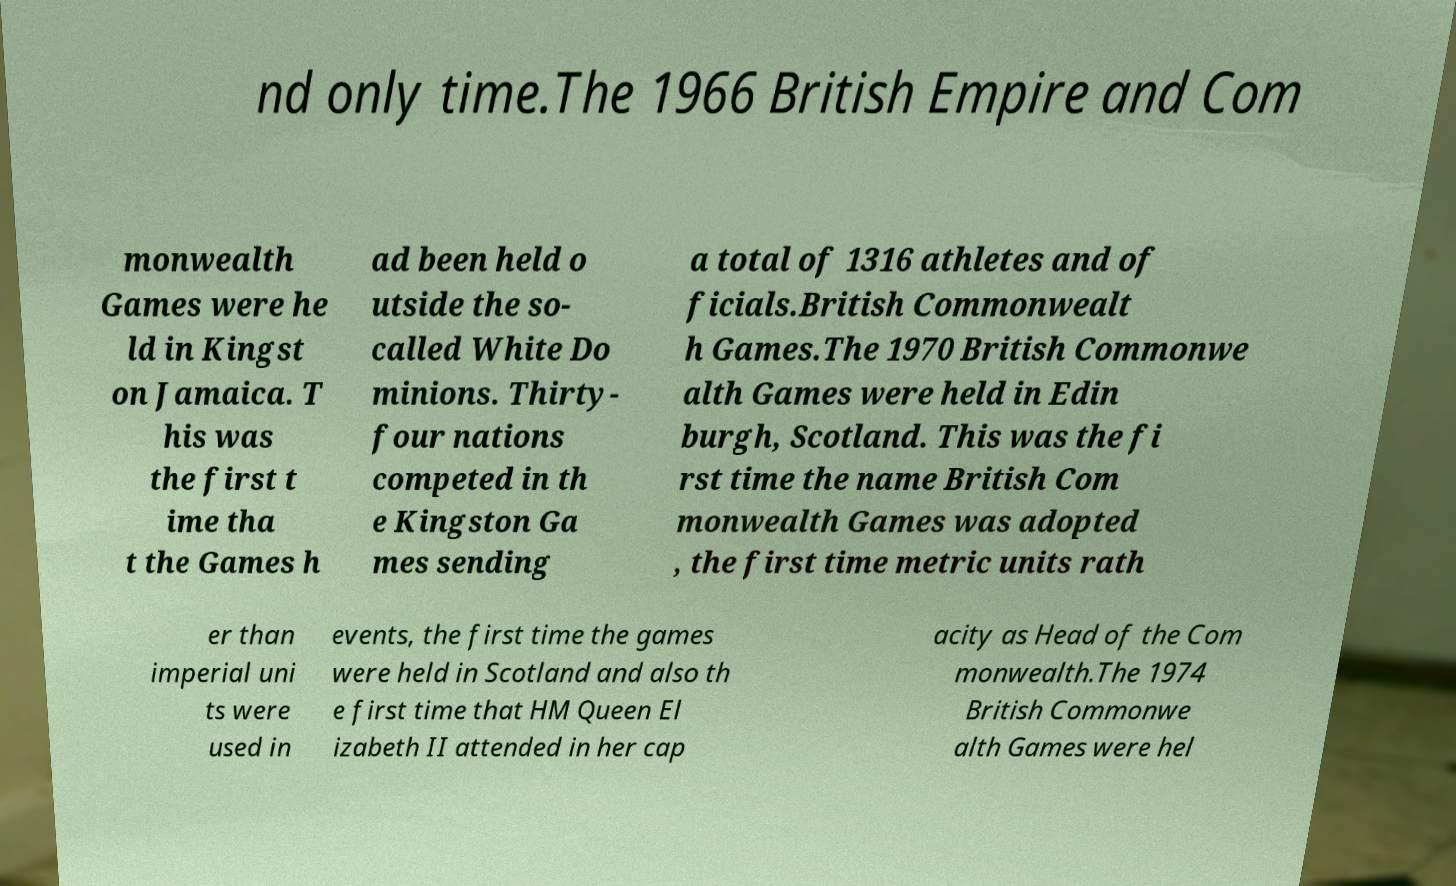For documentation purposes, I need the text within this image transcribed. Could you provide that? nd only time.The 1966 British Empire and Com monwealth Games were he ld in Kingst on Jamaica. T his was the first t ime tha t the Games h ad been held o utside the so- called White Do minions. Thirty- four nations competed in th e Kingston Ga mes sending a total of 1316 athletes and of ficials.British Commonwealt h Games.The 1970 British Commonwe alth Games were held in Edin burgh, Scotland. This was the fi rst time the name British Com monwealth Games was adopted , the first time metric units rath er than imperial uni ts were used in events, the first time the games were held in Scotland and also th e first time that HM Queen El izabeth II attended in her cap acity as Head of the Com monwealth.The 1974 British Commonwe alth Games were hel 